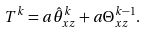<formula> <loc_0><loc_0><loc_500><loc_500>T ^ { k } = a \hat { \theta } ^ { k } _ { x z } + a \Theta ^ { k - 1 } _ { x z } .</formula> 